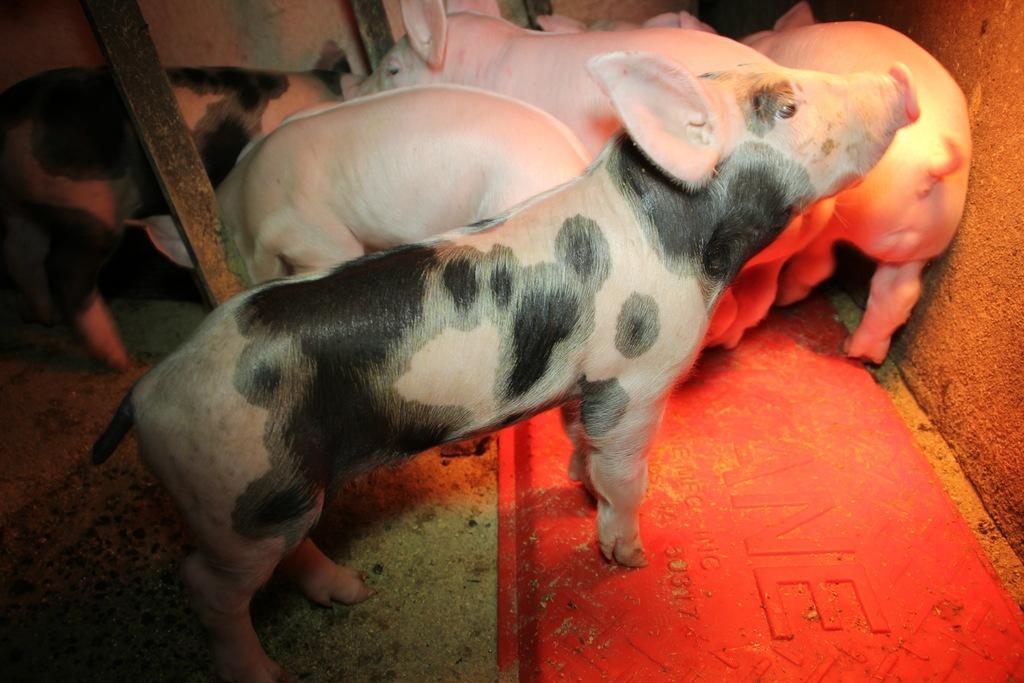How would you summarize this image in a sentence or two? In this image we can see some pigs which are in pink color and some are in pink and black color and in the background of the image there is a wall. 